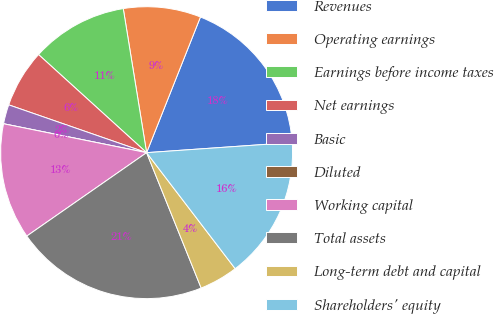<chart> <loc_0><loc_0><loc_500><loc_500><pie_chart><fcel>Revenues<fcel>Operating earnings<fcel>Earnings before income taxes<fcel>Net earnings<fcel>Basic<fcel>Diluted<fcel>Working capital<fcel>Total assets<fcel>Long-term debt and capital<fcel>Shareholders' equity<nl><fcel>17.88%<fcel>8.57%<fcel>10.71%<fcel>6.42%<fcel>2.14%<fcel>0.0%<fcel>12.85%<fcel>21.42%<fcel>4.28%<fcel>15.73%<nl></chart> 